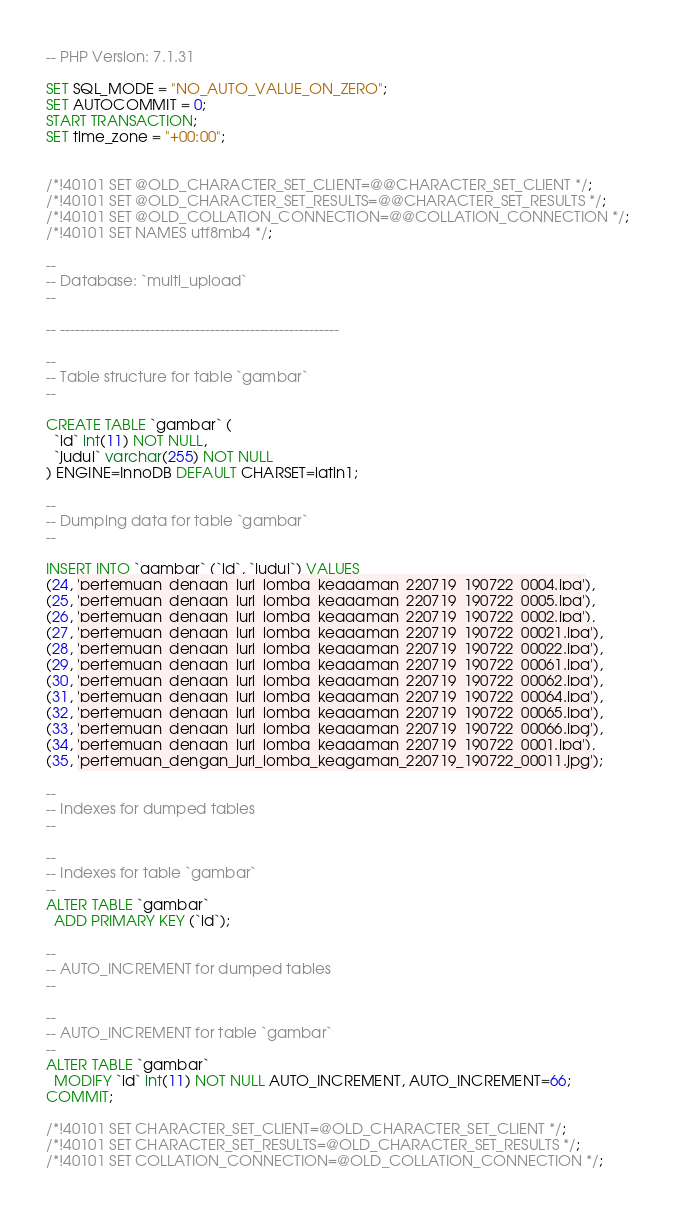<code> <loc_0><loc_0><loc_500><loc_500><_SQL_>-- PHP Version: 7.1.31

SET SQL_MODE = "NO_AUTO_VALUE_ON_ZERO";
SET AUTOCOMMIT = 0;
START TRANSACTION;
SET time_zone = "+00:00";


/*!40101 SET @OLD_CHARACTER_SET_CLIENT=@@CHARACTER_SET_CLIENT */;
/*!40101 SET @OLD_CHARACTER_SET_RESULTS=@@CHARACTER_SET_RESULTS */;
/*!40101 SET @OLD_COLLATION_CONNECTION=@@COLLATION_CONNECTION */;
/*!40101 SET NAMES utf8mb4 */;

--
-- Database: `multi_upload`
--

-- --------------------------------------------------------

--
-- Table structure for table `gambar`
--

CREATE TABLE `gambar` (
  `id` int(11) NOT NULL,
  `judul` varchar(255) NOT NULL
) ENGINE=InnoDB DEFAULT CHARSET=latin1;

--
-- Dumping data for table `gambar`
--

INSERT INTO `gambar` (`id`, `judul`) VALUES
(24, 'pertemuan_dengan_juri_lomba_keagaman_220719_190722_0004.jpg'),
(25, 'pertemuan_dengan_juri_lomba_keagaman_220719_190722_0005.jpg'),
(26, 'pertemuan_dengan_juri_lomba_keagaman_220719_190722_0002.jpg'),
(27, 'pertemuan_dengan_juri_lomba_keagaman_220719_190722_00021.jpg'),
(28, 'pertemuan_dengan_juri_lomba_keagaman_220719_190722_00022.jpg'),
(29, 'pertemuan_dengan_juri_lomba_keagaman_220719_190722_00061.jpg'),
(30, 'pertemuan_dengan_juri_lomba_keagaman_220719_190722_00062.jpg'),
(31, 'pertemuan_dengan_juri_lomba_keagaman_220719_190722_00064.jpg'),
(32, 'pertemuan_dengan_juri_lomba_keagaman_220719_190722_00065.jpg'),
(33, 'pertemuan_dengan_juri_lomba_keagaman_220719_190722_00066.jpg'),
(34, 'pertemuan_dengan_juri_lomba_keagaman_220719_190722_0001.jpg'),
(35, 'pertemuan_dengan_juri_lomba_keagaman_220719_190722_00011.jpg');

--
-- Indexes for dumped tables
--

--
-- Indexes for table `gambar`
--
ALTER TABLE `gambar`
  ADD PRIMARY KEY (`id`);

--
-- AUTO_INCREMENT for dumped tables
--

--
-- AUTO_INCREMENT for table `gambar`
--
ALTER TABLE `gambar`
  MODIFY `id` int(11) NOT NULL AUTO_INCREMENT, AUTO_INCREMENT=66;
COMMIT;

/*!40101 SET CHARACTER_SET_CLIENT=@OLD_CHARACTER_SET_CLIENT */;
/*!40101 SET CHARACTER_SET_RESULTS=@OLD_CHARACTER_SET_RESULTS */;
/*!40101 SET COLLATION_CONNECTION=@OLD_COLLATION_CONNECTION */;
</code> 